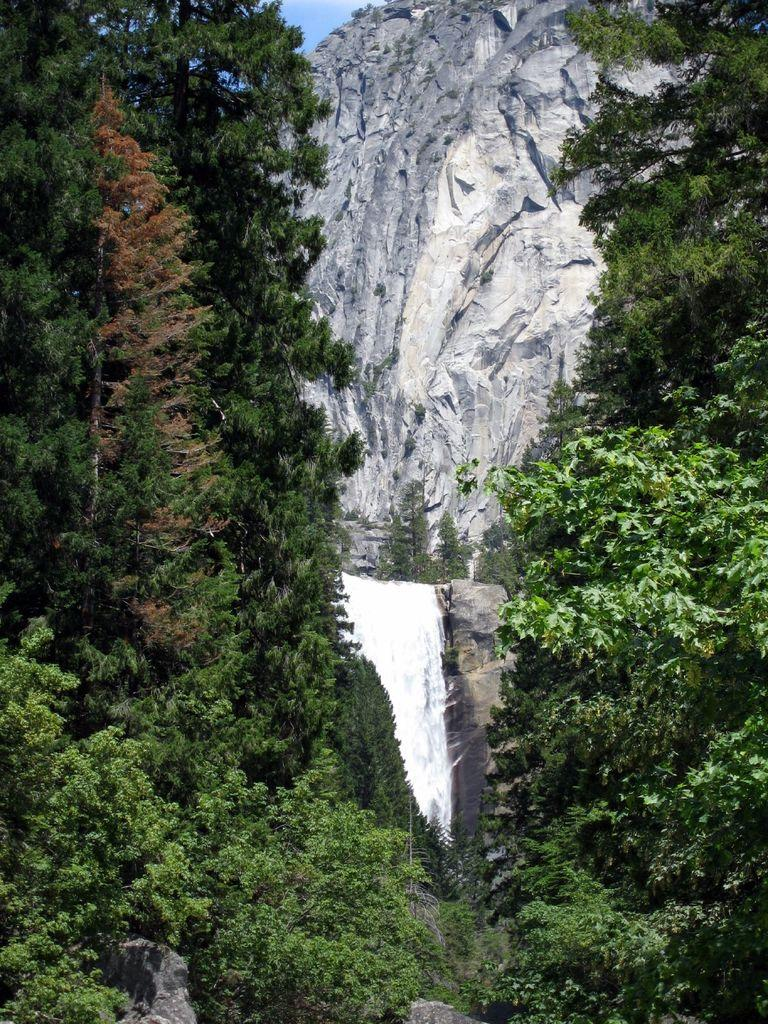What type of vegetation is present in the image? There are trees in the image. What geographical features can be seen in the image? There are hills in the image. What is visible behind the hills in the image? The sky is visible behind the hills. What type of account is being discussed in the image? There is no account being discussed in the image; it features trees, hills, and the sky. 